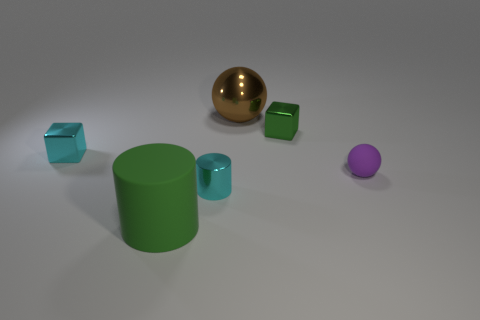The sphere in front of the large thing that is behind the ball in front of the brown metallic sphere is what color?
Your response must be concise. Purple. There is a metal block that is right of the big object that is left of the brown ball; what size is it?
Make the answer very short. Small. What material is the object that is both behind the tiny cyan metal cube and in front of the shiny sphere?
Keep it short and to the point. Metal. There is a brown metal sphere; does it have the same size as the cylinder behind the big cylinder?
Make the answer very short. No. Is there a big cyan block?
Your response must be concise. No. What material is the other small thing that is the same shape as the brown thing?
Your answer should be compact. Rubber. There is a metal block to the right of the large thing that is to the left of the small cyan thing in front of the purple sphere; what size is it?
Your response must be concise. Small. Are there any small rubber balls to the left of the tiny cyan cylinder?
Offer a terse response. No. What size is the green thing that is made of the same material as the small sphere?
Ensure brevity in your answer.  Large. How many big gray objects have the same shape as the tiny purple matte thing?
Offer a terse response. 0. 